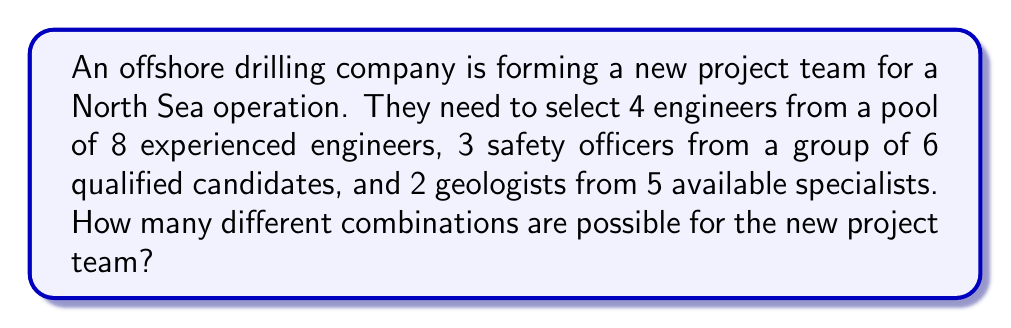Teach me how to tackle this problem. Let's break this down step-by-step:

1) For the engineers:
   We need to choose 4 out of 8 engineers. This is a combination problem, represented as $C(8,4)$ or $\binom{8}{4}$.
   $$\binom{8}{4} = \frac{8!}{4!(8-4)!} = \frac{8!}{4!4!} = 70$$

2) For the safety officers:
   We need to choose 3 out of 6 safety officers. This is $C(6,3)$ or $\binom{6}{3}$.
   $$\binom{6}{3} = \frac{6!}{3!(6-3)!} = \frac{6!}{3!3!} = 20$$

3) For the geologists:
   We need to choose 2 out of 5 geologists. This is $C(5,2)$ or $\binom{5}{2}$.
   $$\binom{5}{2} = \frac{5!}{2!(5-2)!} = \frac{5!}{2!3!} = 10$$

4) Now, according to the Multiplication Principle, if we have 70 ways to choose the engineers, 20 ways to choose the safety officers, and 10 ways to choose the geologists, the total number of possible combinations is:

   $$70 \times 20 \times 10 = 14,000$$

Therefore, there are 14,000 different possible combinations for the new project team.
Answer: 14,000 